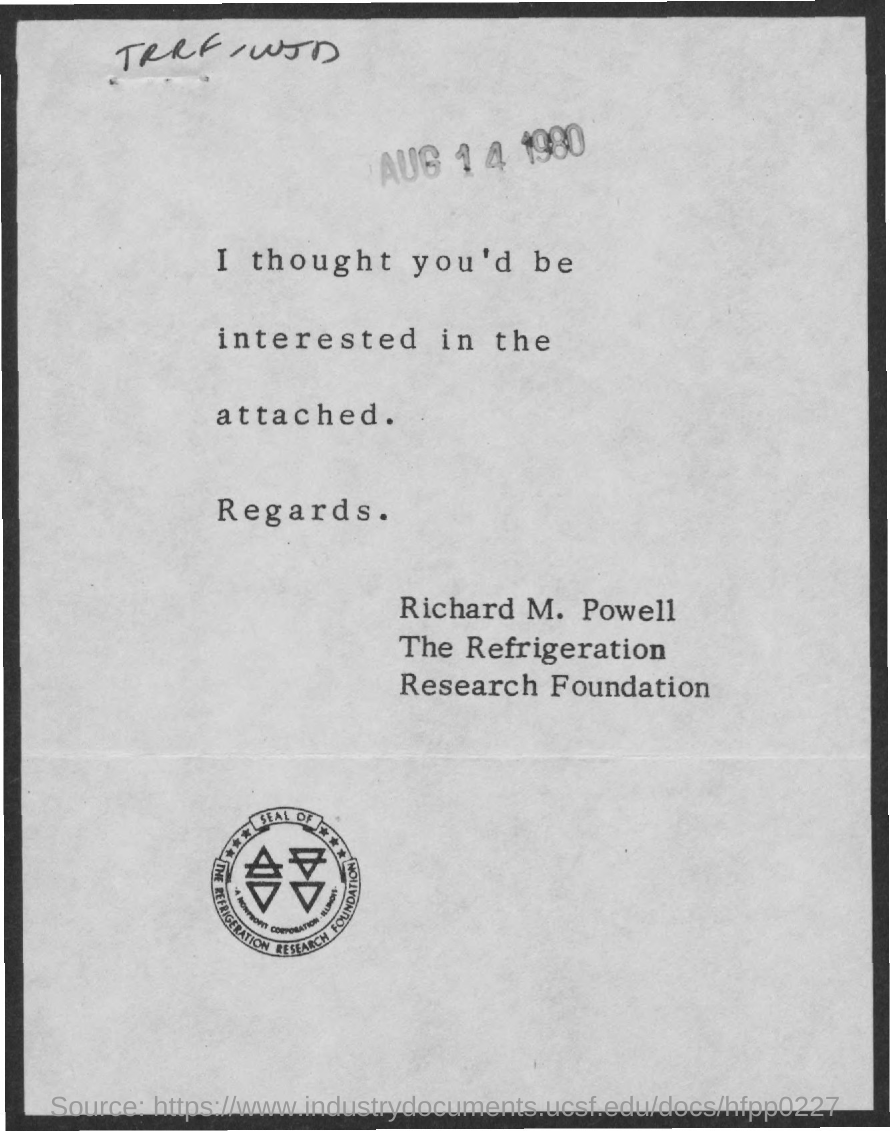What is the date mentioned ?
Keep it short and to the point. AUG 14 1980. 